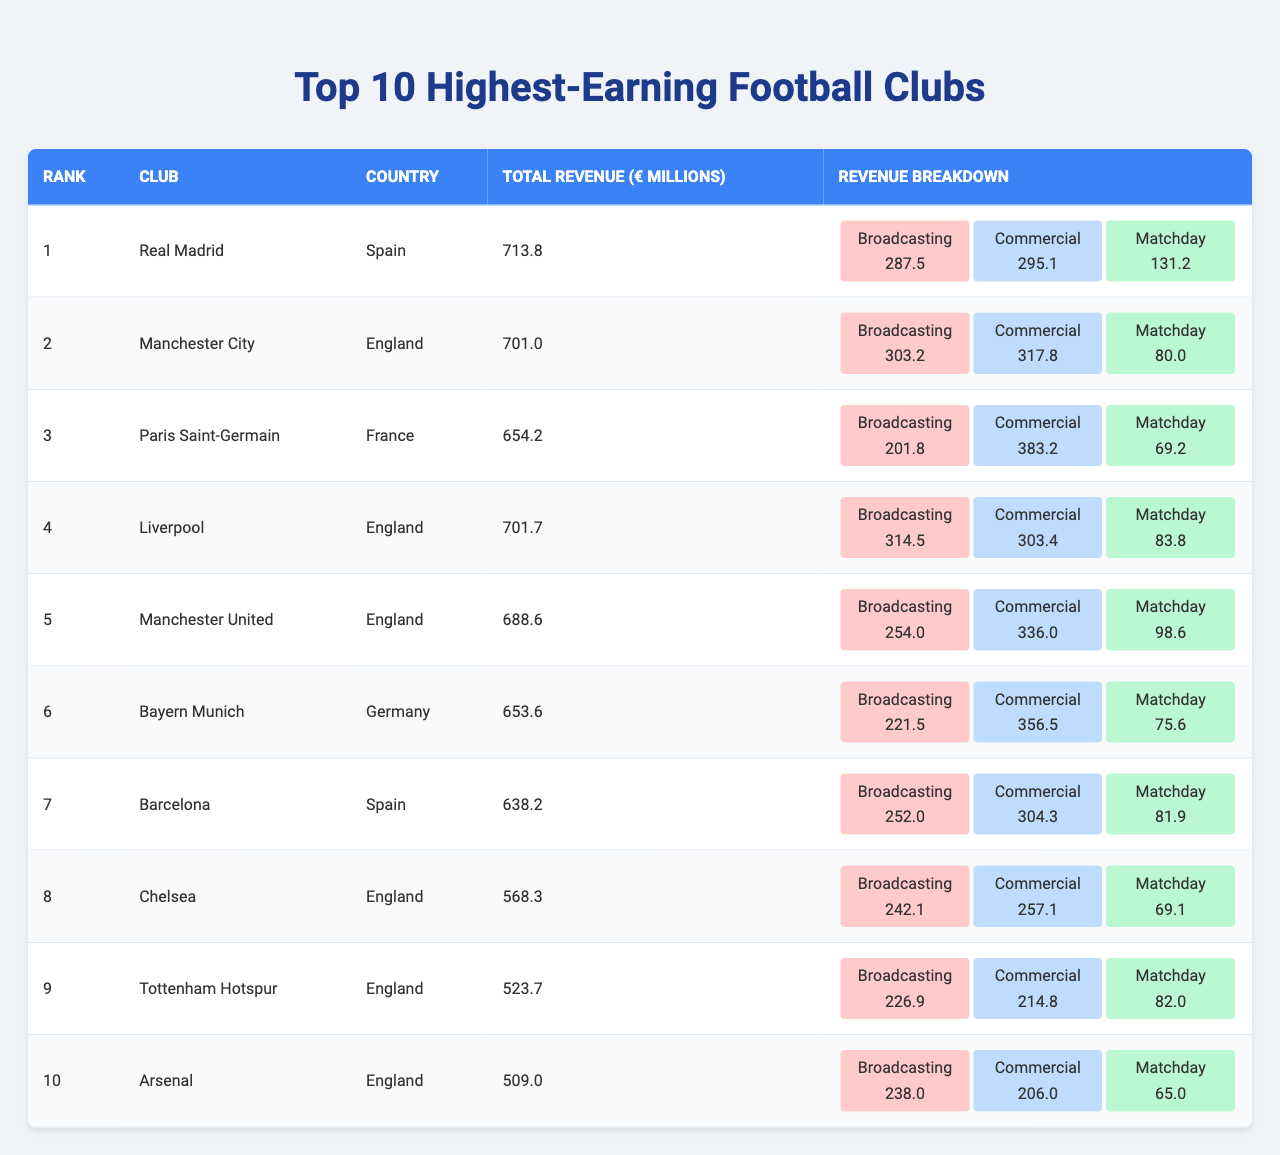What is the total revenue of Liverpool? The table shows that Liverpool has a total revenue of 701.7 million euros.
Answer: 701.7 million euros Which club has the highest broadcasting revenue? Looking at the broadcasting revenue figures, Manchester City has the highest at 303.2 million euros.
Answer: Manchester City What percentage of Manchester United's total revenue comes from matchday? Manchester United's matchday revenue is 98.6 million euros out of a total revenue of 688.6 million euros. To find the percentage, divide 98.6 by 688.6 and multiply by 100: (98.6 / 688.6) * 100 ≈ 14.3%.
Answer: Approximately 14.3% Which club earns more: Bayern Munich's commercial revenue or Chelsea's commercial revenue? Bayern Munich's commercial revenue is 356.5 million euros, while Chelsea's is 257.1 million euros. Since 356.5 is greater than 257.1, Bayern Munich earns more.
Answer: Bayern Munich What is the average total revenue of the top 10 clubs? To find the average total revenue, sum the total revenues of all clubs: (713.8 + 701.0 + 654.2 + 701.7 + 688.6 + 653.6 + 638.2 + 568.3 + 523.7 + 509.0) = 5908.1 million euros. Then divide by 10: 5908.1 / 10 = 590.81 million euros.
Answer: 590.81 million euros Does any club have equal broadcasting and commercial revenues? Reviewing the broadcasting and commercial revenues for each club shows that no club has equal values for those categories.
Answer: No Which country has the most clubs in the top 10 highest-earning clubs? Upon examining the countries listed, England has five clubs (Manchester City, Liverpool, Manchester United, Chelsea, Tottenham Hotspur, Arsenal), which is more than any other country.
Answer: England What is the total matchday revenue from the top 10 clubs? The matchday revenues are as follows: 131.2 (Real Madrid) + 80.0 (Manchester City) + 69.2 (Paris Saint-Germain) + 83.8 (Liverpool) + 98.6 (Manchester United) + 75.6 (Bayern Munich) + 81.9 (Barcelona) + 69.1 (Chelsea) + 82.0 (Tottenham Hotspur) + 65.0 (Arsenal) =  610.4 million euros.
Answer: 610.4 million euros What is the difference in total revenue between the highest-earning club and the lowest-earning club? The highest-earning club is Real Madrid with 713.8 million euros, and the lowest is Arsenal with 509.0 million euros. The difference is 713.8 - 509.0 = 204.8 million euros.
Answer: 204.8 million euros Which two clubs have the closest total revenues, and what is the difference? Liverpool (701.7 million euros) and Manchester City (701.0 million euros) have the closest revenues. The difference is 701.7 - 701.0 = 0.7 million euros.
Answer: Liverpool and Manchester City, difference of 0.7 million euros 